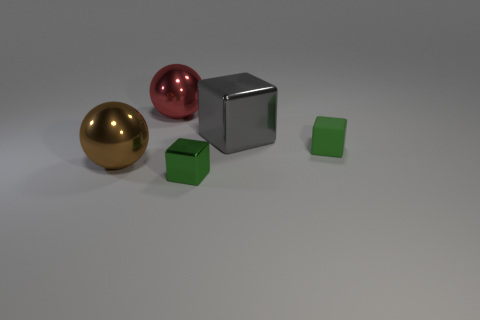The other cube that is the same size as the green shiny block is what color?
Make the answer very short. Green. Do the big gray thing and the small thing that is behind the small green metal object have the same shape?
Ensure brevity in your answer.  Yes. There is a small thing that is behind the big shiny thing that is in front of the green thing on the right side of the large metal cube; what is it made of?
Provide a succinct answer. Rubber. What number of big things are cyan rubber spheres or gray cubes?
Provide a succinct answer. 1. How many other objects are the same size as the gray block?
Keep it short and to the point. 2. There is a large thing to the left of the red metallic thing; does it have the same shape as the tiny matte thing?
Provide a short and direct response. No. There is a large shiny thing that is the same shape as the small green metal thing; what color is it?
Your response must be concise. Gray. Are there an equal number of large shiny objects that are to the right of the large brown metal sphere and big metallic balls?
Give a very brief answer. Yes. How many things are both in front of the big cube and on the left side of the small green shiny cube?
Your response must be concise. 1. There is a green rubber thing that is the same shape as the gray object; what is its size?
Your answer should be very brief. Small. 